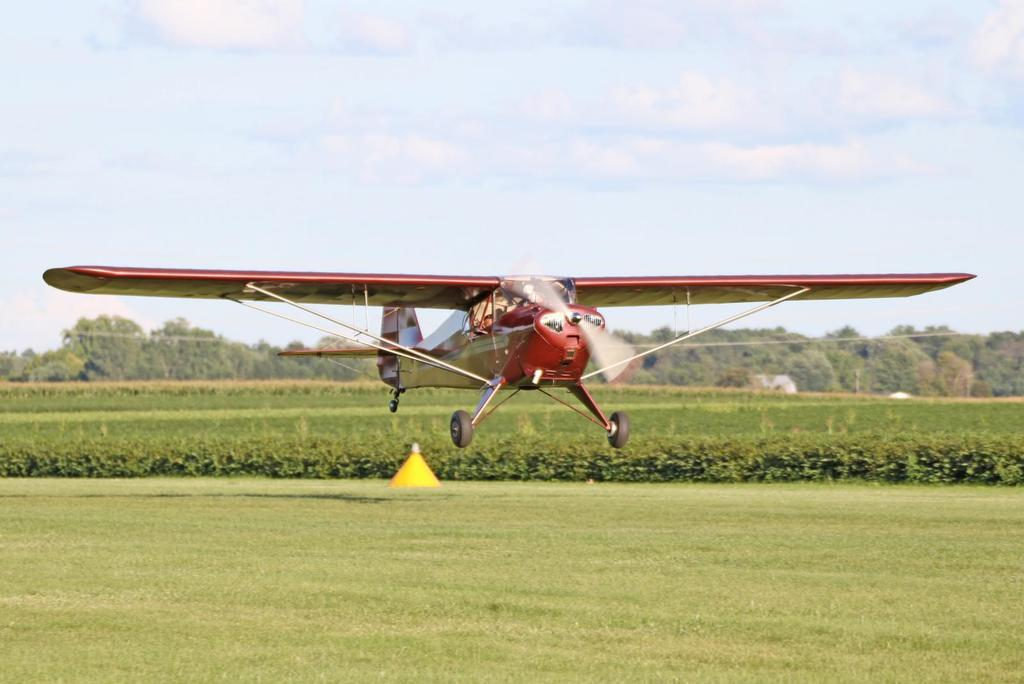What is the main subject of the image? The main subject of the image is an airplane. Where is the airplane located in the image? The airplane is in the air. What type of vegetation can be seen in the image? There is grass, plants, and trees visible in the image. What is visible in the background of the image? The sky is visible in the background of the image, with clouds present. What type of discussion is taking place between the spiders in the image? There are no spiders present in the image, so no discussion can be observed. How does the airplane's acoustics affect the surrounding environment in the image? The image does not provide information about the airplane's acoustics or its effect on the surrounding environment. 